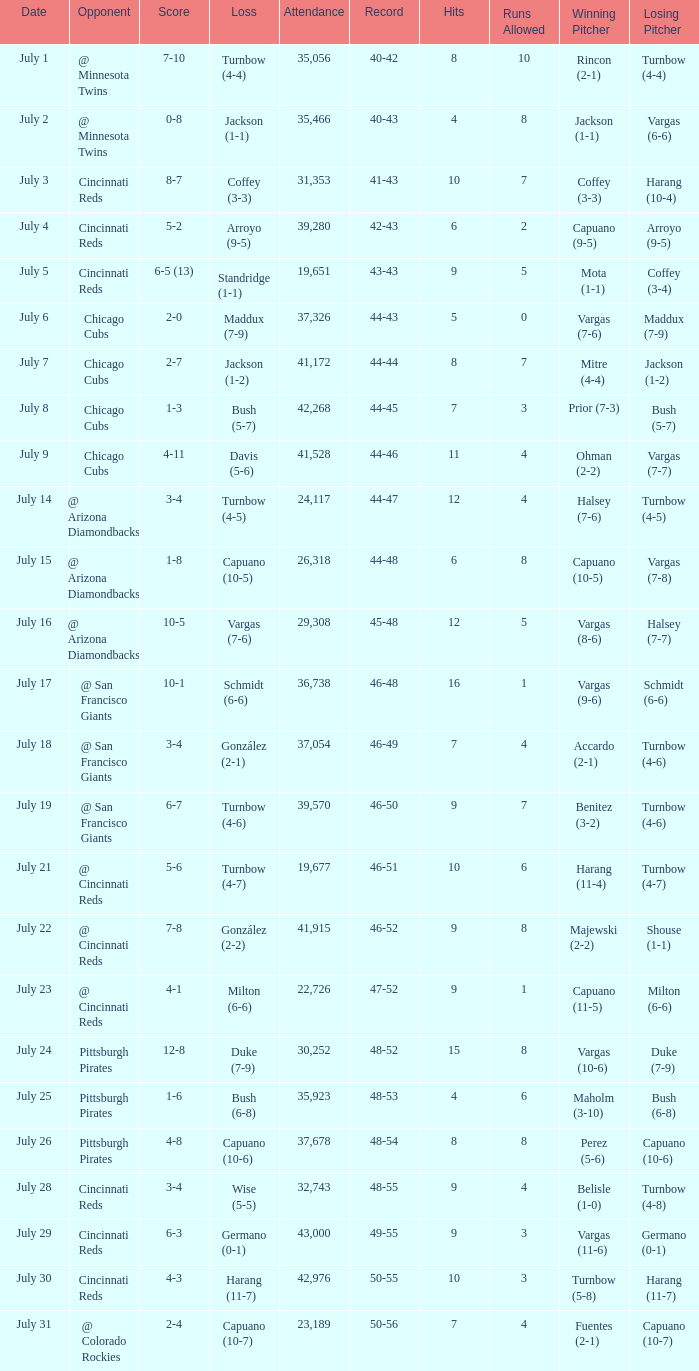What was the loss of the Brewers game when the record was 46-48? Schmidt (6-6). 